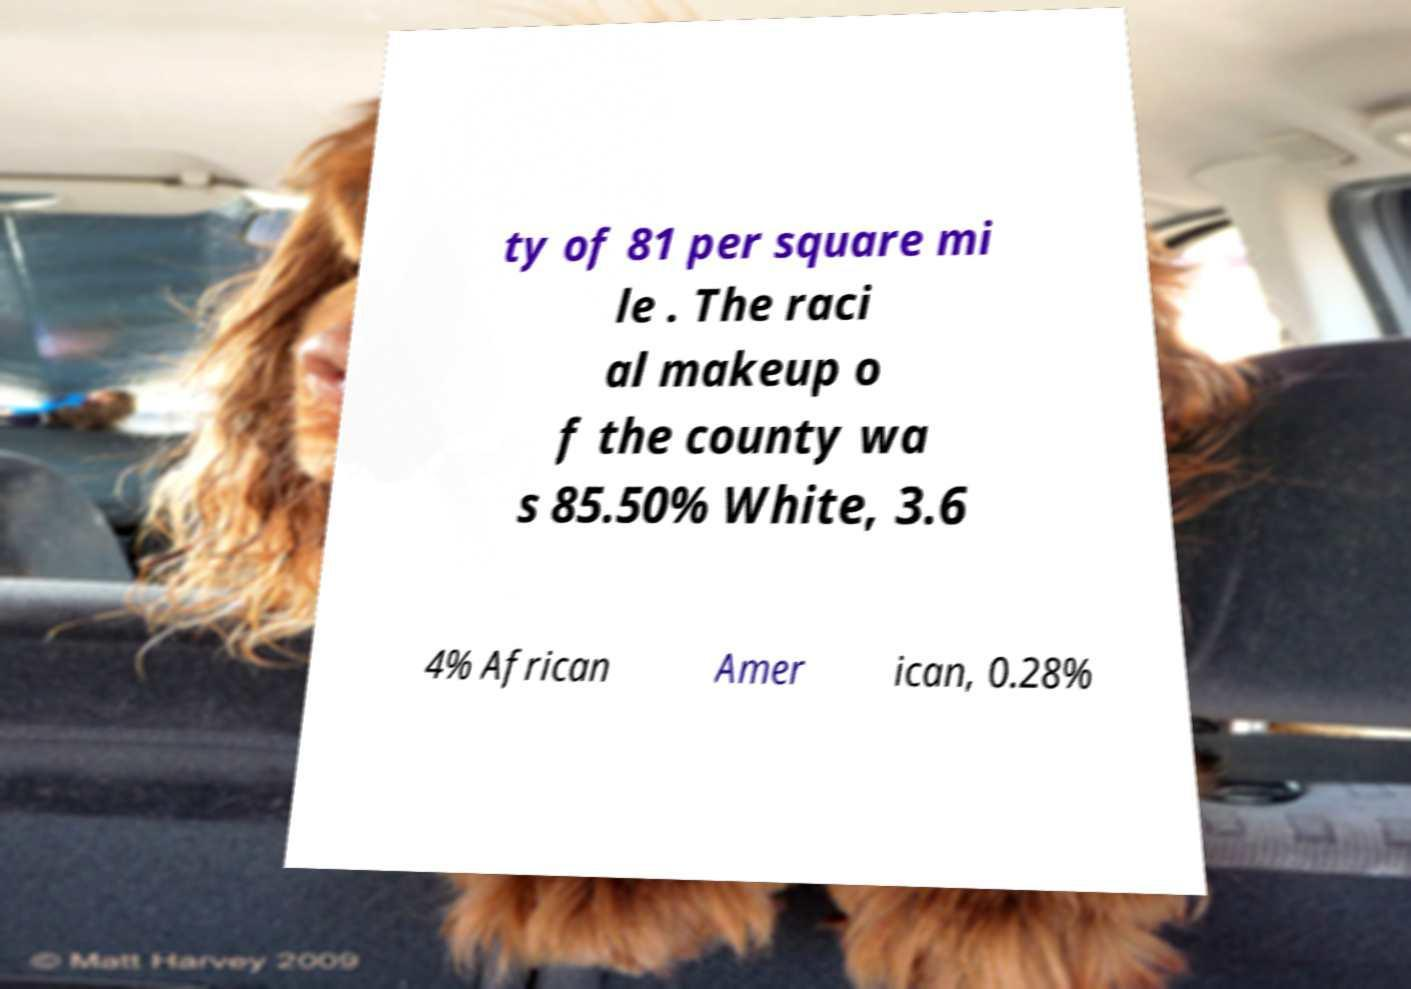Please identify and transcribe the text found in this image. ty of 81 per square mi le . The raci al makeup o f the county wa s 85.50% White, 3.6 4% African Amer ican, 0.28% 